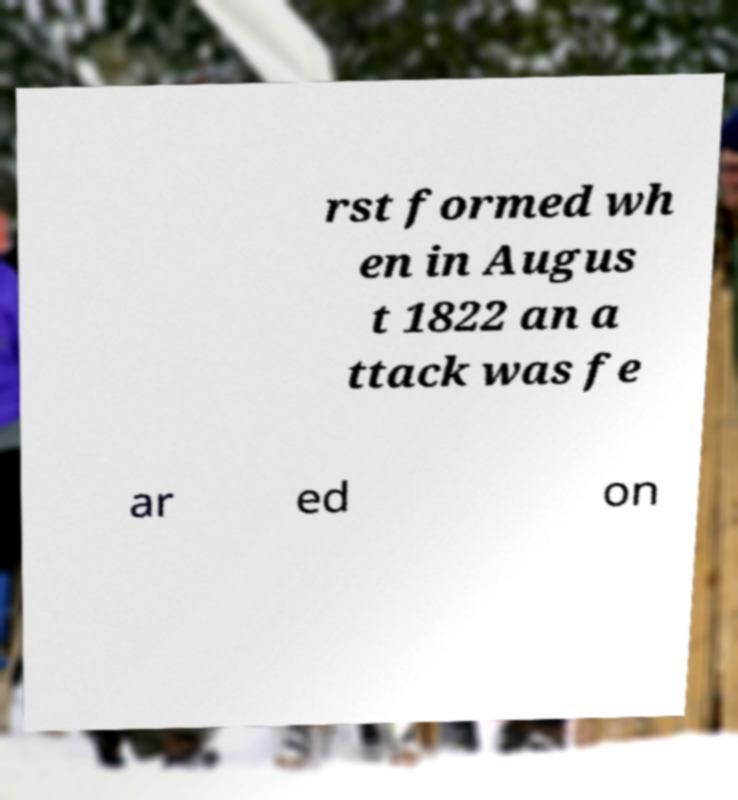There's text embedded in this image that I need extracted. Can you transcribe it verbatim? rst formed wh en in Augus t 1822 an a ttack was fe ar ed on 